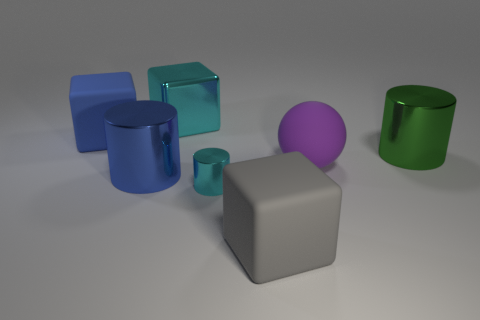Does the cyan metal thing that is behind the green metallic cylinder have the same size as the large matte ball?
Provide a succinct answer. Yes. What number of other objects are there of the same color as the tiny object?
Keep it short and to the point. 1. What number of small yellow cylinders are made of the same material as the large green cylinder?
Ensure brevity in your answer.  0. Is the color of the small metallic cylinder that is right of the cyan block the same as the sphere?
Give a very brief answer. No. What number of brown objects are either big rubber spheres or shiny cylinders?
Your answer should be compact. 0. Is there any other thing that has the same material as the big ball?
Make the answer very short. Yes. Do the block in front of the big green metallic cylinder and the blue cylinder have the same material?
Keep it short and to the point. No. What number of objects are either large cyan cubes or matte blocks to the right of the small cyan cylinder?
Your answer should be compact. 2. How many green objects are left of the metal thing that is right of the matte block to the right of the tiny thing?
Your response must be concise. 0. There is a big matte thing that is left of the big gray rubber block; does it have the same shape as the green object?
Your answer should be very brief. No. 